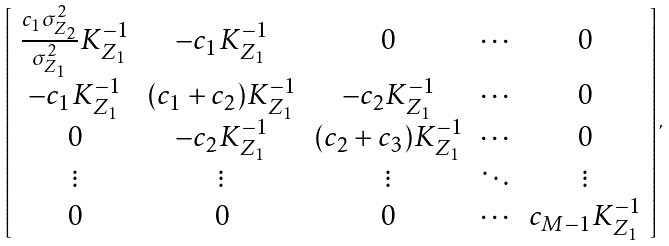<formula> <loc_0><loc_0><loc_500><loc_500>\left [ \begin{array} { c c c c c } \frac { c _ { 1 } \sigma _ { Z _ { 2 } } ^ { 2 } } { \sigma _ { Z _ { 1 } } ^ { 2 } } K _ { Z _ { 1 } } ^ { - 1 } & - c _ { 1 } K _ { Z _ { 1 } } ^ { - 1 } & 0 & \cdots & 0 \\ - c _ { 1 } K _ { Z _ { 1 } } ^ { - 1 } & ( c _ { 1 } + c _ { 2 } ) K _ { Z _ { 1 } } ^ { - 1 } & - c _ { 2 } K _ { Z _ { 1 } } ^ { - 1 } & \cdots & 0 \\ 0 & - c _ { 2 } K _ { Z _ { 1 } } ^ { - 1 } & ( c _ { 2 } + c _ { 3 } ) K _ { Z _ { 1 } } ^ { - 1 } & \cdots & 0 \\ \vdots & \vdots & \vdots & \ddots & \vdots \\ 0 & 0 & 0 & \cdots & c _ { M - 1 } K _ { Z _ { 1 } } ^ { - 1 } \end{array} \right ] ,</formula> 